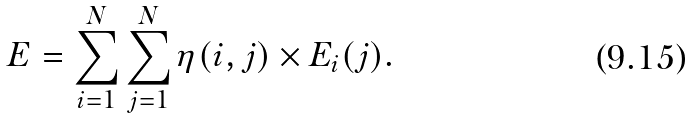<formula> <loc_0><loc_0><loc_500><loc_500>E = \sum _ { i = 1 } ^ { N } \sum _ { j = 1 } ^ { N } \eta ( i , j ) \times E _ { i } ( j ) .</formula> 